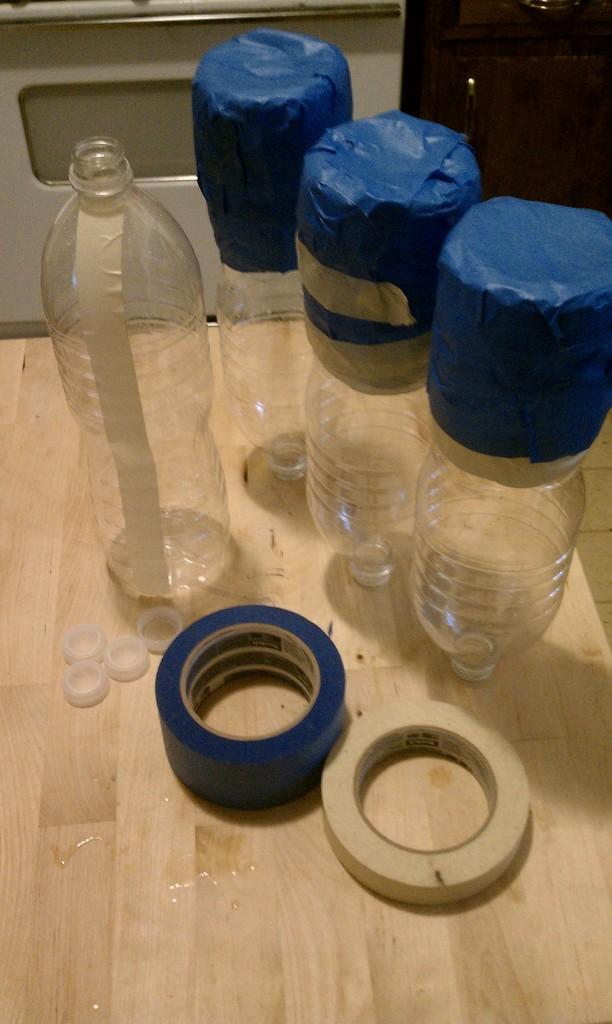Where was the image taken? The image was taken inside a room. What type of furniture is present in the room? There is a wooden table in the room. What objects can be seen on the table? There are empty bottles and two plasters on the table. Is there a way to enter or exit the room? Yes, there is a door in the room. What type of organization is represented by the team in the garden in the image? There is no garden, organization, or team present in the image. 